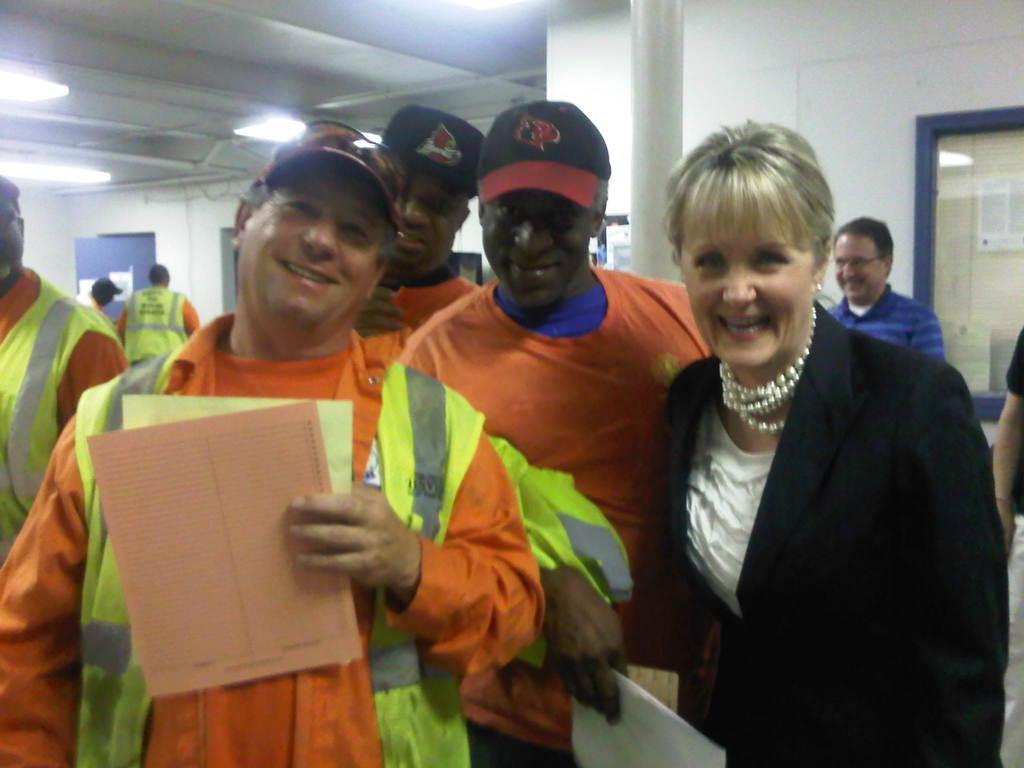In one or two sentences, can you explain what this image depicts? In this picture there are people, among them there are two men holding papers. In the background of the image we can see wall, pillar, boards and lights. 